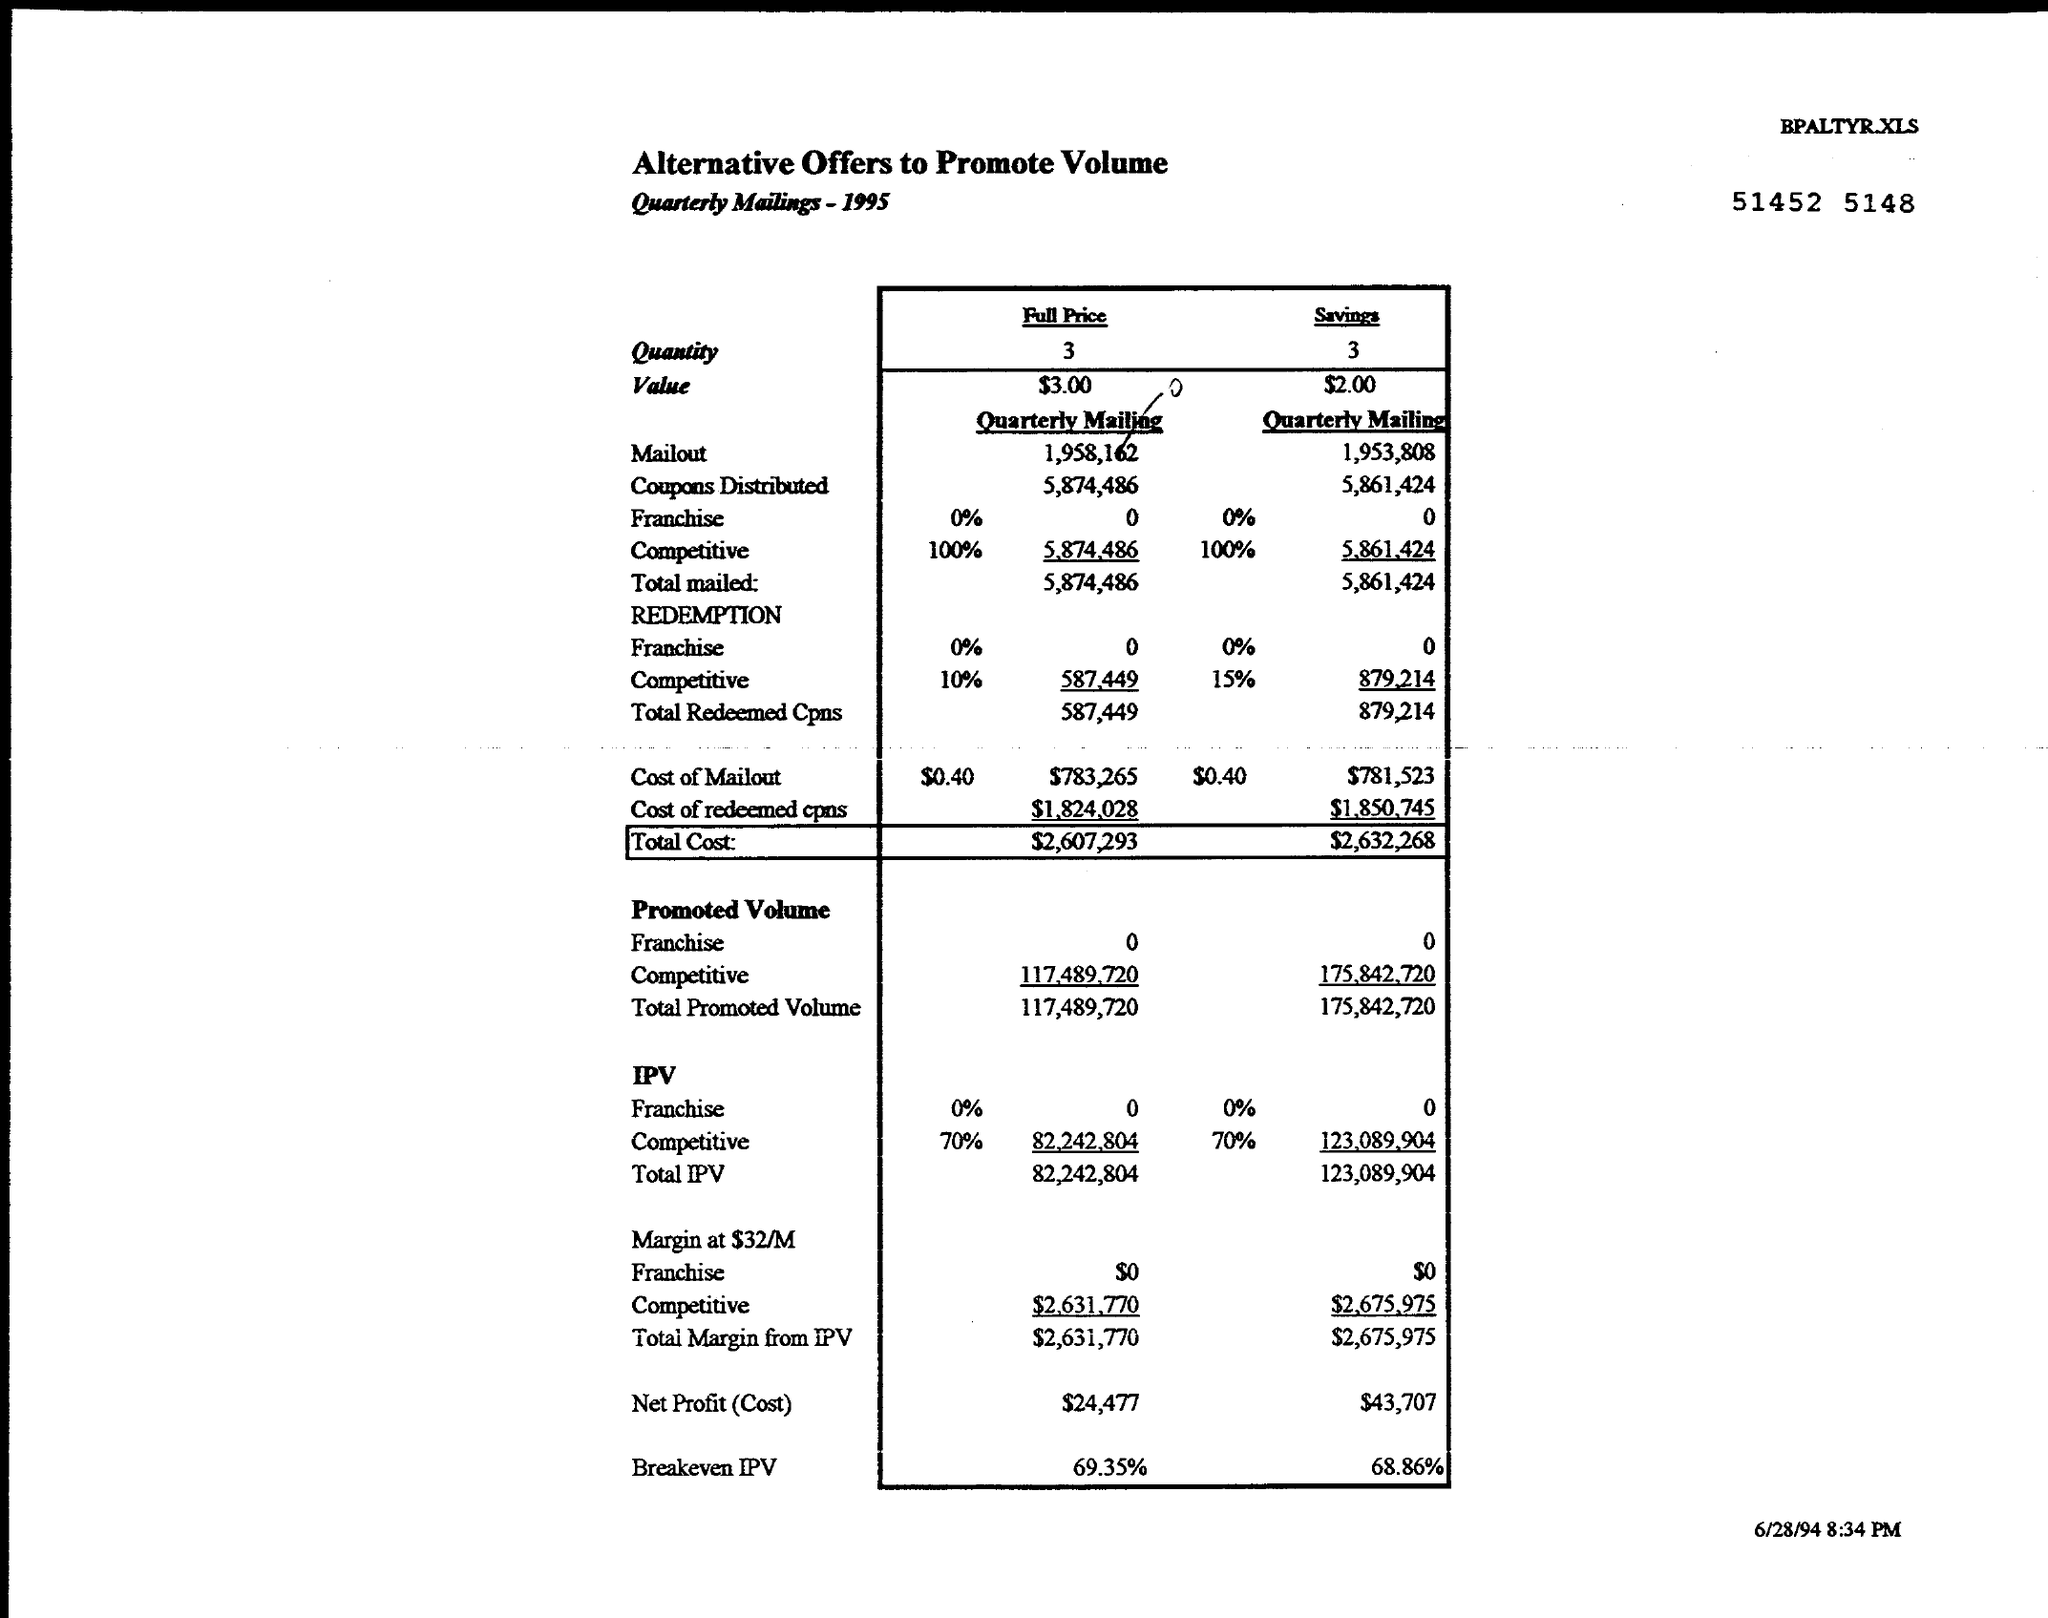Outline some significant characteristics in this image. The "Savings" for the month was $43,707. The full price of the quantity 3 is what? The total cost for savings is $2,632,268. The quantity of savings is 3. The value of the "Savings" category is $2.00. 